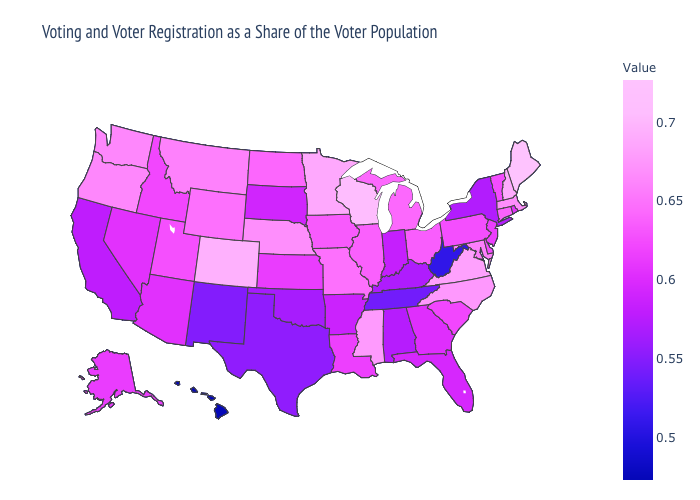Among the states that border Oklahoma , which have the highest value?
Keep it brief. Colorado. Does the map have missing data?
Keep it brief. No. Does Maine have a higher value than Alaska?
Answer briefly. Yes. Which states have the lowest value in the MidWest?
Concise answer only. Indiana. Does Nevada have a lower value than Colorado?
Answer briefly. Yes. Which states have the lowest value in the USA?
Quick response, please. Hawaii. Among the states that border Michigan , which have the lowest value?
Write a very short answer. Indiana. 